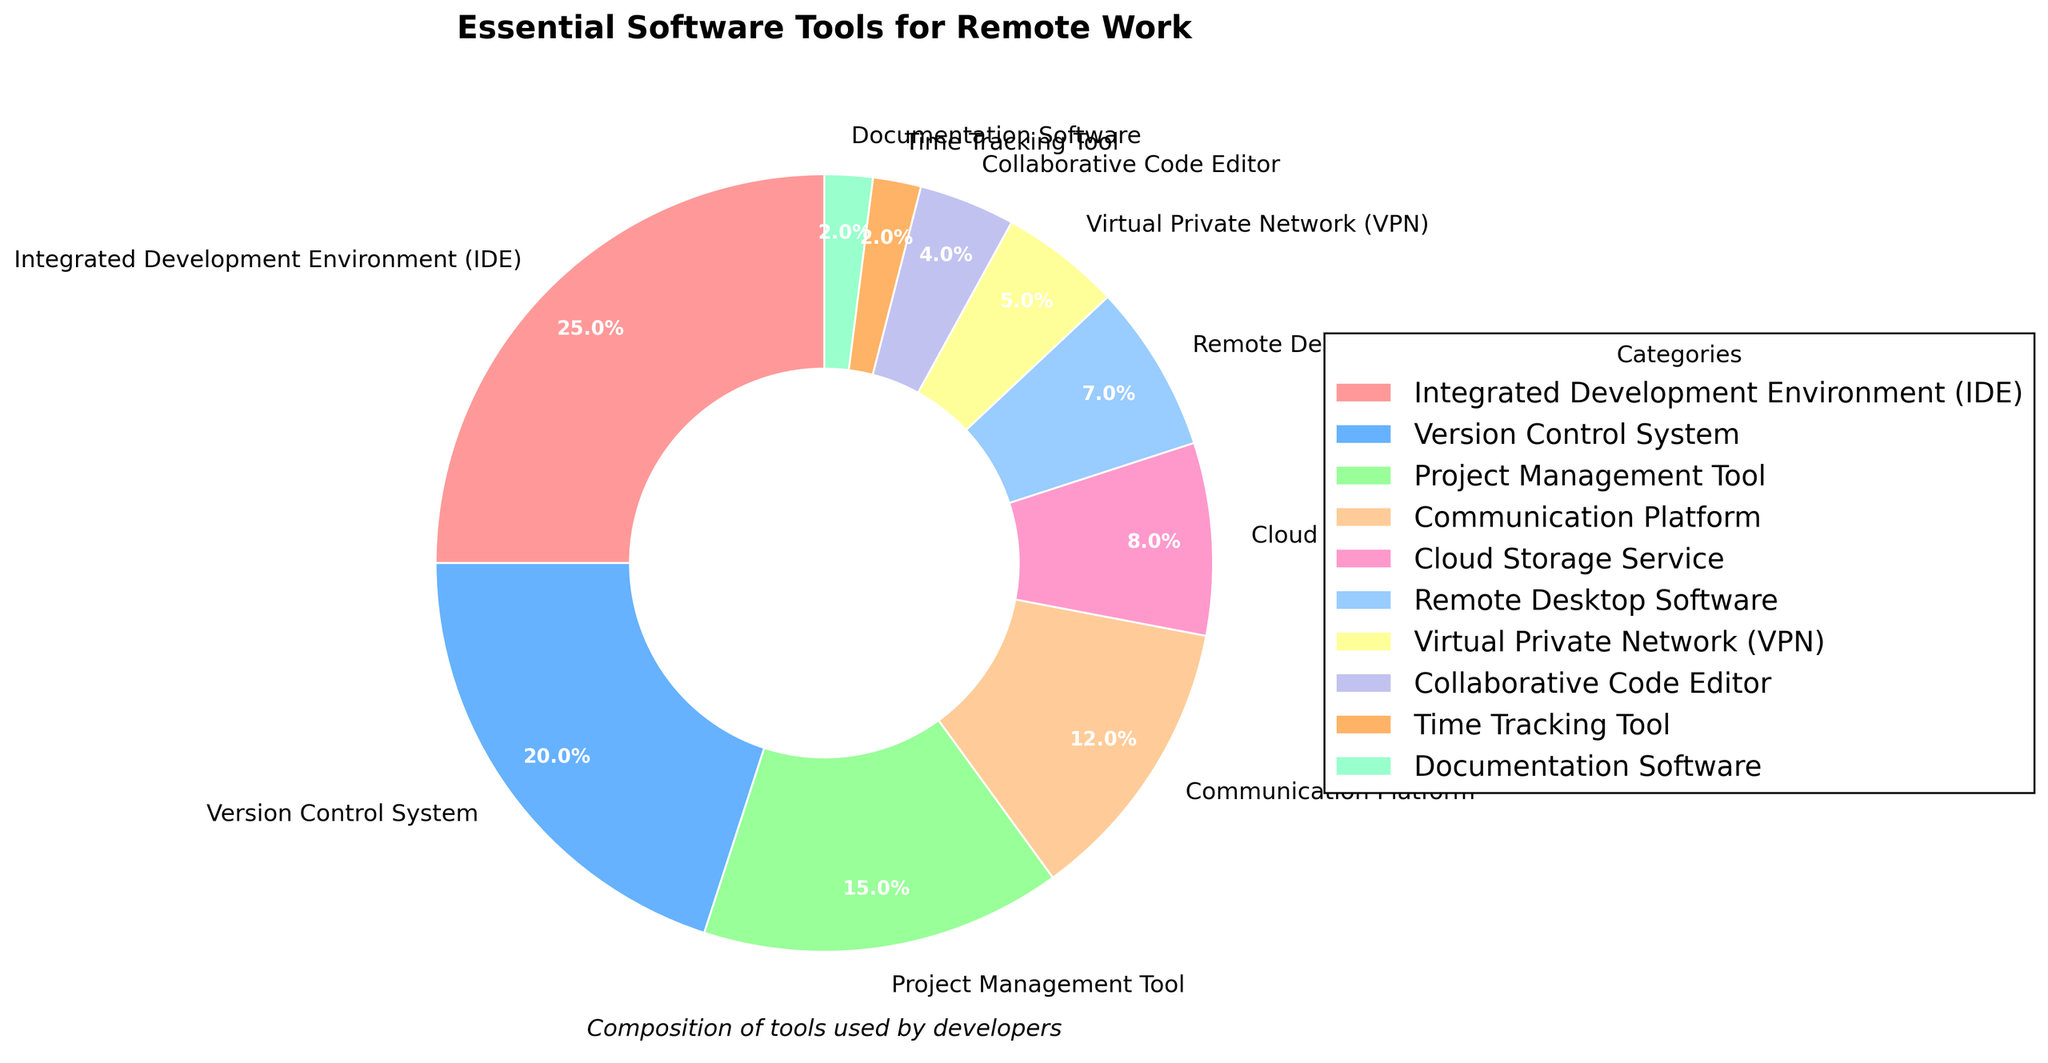What's the percentage of tools related to communication and collaboration (Communication Platform, Collaborative Code Editor, and Remote Desktop Software)? Summing up the percentages of Communication Platform (12%), Collaborative Code Editor (4%), and Remote Desktop Software (7%) gives 12 + 4 + 7 = 23%.
Answer: 23% What is the difference in percentage between the most commonly used and least commonly used tools? The most commonly used tool is Integrated Development Environment (IDE) at 25%, and the least used tools are Time Tracking Tool and Documentation Software, each at 2%. The difference is 25 - 2 = 23%.
Answer: 23% Which category has a higher percentage: Project Management Tool or Version Control System? Project Management Tool has a percentage of 15%, while Version Control System has a percentage of 20%. Since 20 is greater than 15, Version Control System has a higher percentage.
Answer: Version Control System How much more popular is Cloud Storage Service compared to VPN? Cloud Storage Service has a percentage of 8%, and VPN has a percentage of 5%. The difference is 8 - 5 = 3%.
Answer: 3% If Integrated Development Environment (IDE) and Version Control System are combined, what percentage of the pie chart would they represent? The percentage for IDE is 25% and for Version Control System is 20%. Combined, they represent 25 + 20 = 45%.
Answer: 45% Which category, represented by a blue section, is used by developers? The category represented by a blue section is Version Control System.
Answer: Version Control System What is the cumulative percentage of all tools that have a percentage lower than 10%? The tools with percentages lower than 10% are Cloud Storage Service (8%), Remote Desktop Software (7%), VPN (5%), Collaborative Code Editor (4%), Time Tracking Tool (2%), and Documentation Software (2%). Their cumulative percentage is 8 + 7 + 5 + 4 + 2 + 2 = 28%.
Answer: 28% What is the visual attribute that differentiates Time Tracking Tool from Project Management Tool in the pie chart? Time Tracking Tool and Project Management Tool have different colors. Time Tracking Tool is represented by a light green section while Project Management Tool is in light orange.
Answer: color Which category occupies the largest section of the pie chart? The category with the largest section of the pie chart is Integrated Development Environment (IDE).
Answer: Integrated Development Environment (IDE) If you were to shade every category that represents 15% or more, name the categories that would be shaded? The categories with 15% or more are Integrated Development Environment (25%), Version Control System (20%), and Project Management Tool (15%).
Answer: Integrated Development Environment, Version Control System, Project Management Tool 